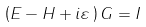Convert formula to latex. <formula><loc_0><loc_0><loc_500><loc_500>\left ( E - H + i \varepsilon \mathcal { \, } \right ) G = I</formula> 